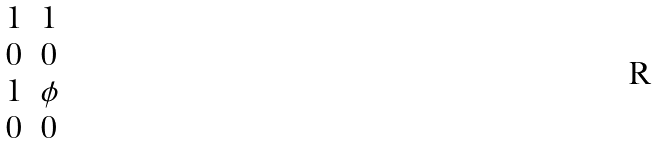Convert formula to latex. <formula><loc_0><loc_0><loc_500><loc_500>\begin{matrix} 1 & 1 \\ 0 & 0 \\ 1 & \phi \\ 0 & 0 \end{matrix}</formula> 